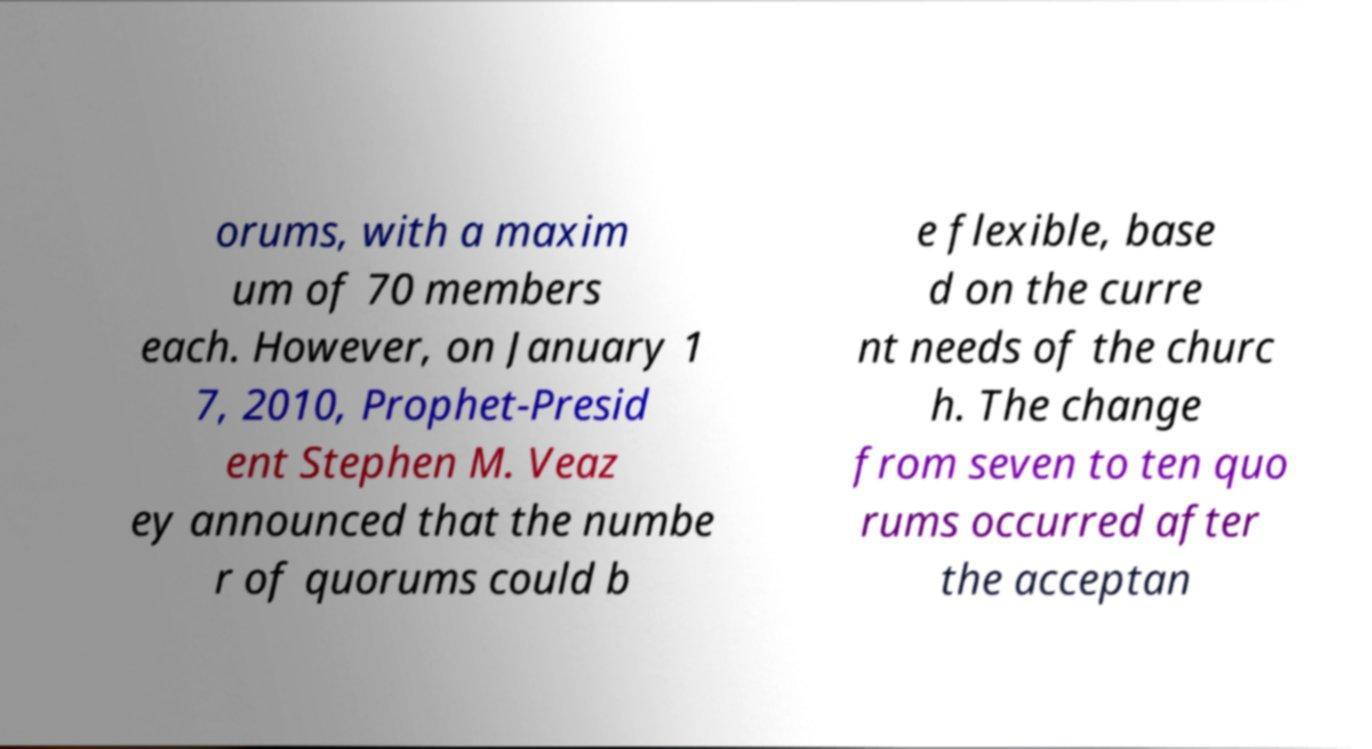There's text embedded in this image that I need extracted. Can you transcribe it verbatim? orums, with a maxim um of 70 members each. However, on January 1 7, 2010, Prophet-Presid ent Stephen M. Veaz ey announced that the numbe r of quorums could b e flexible, base d on the curre nt needs of the churc h. The change from seven to ten quo rums occurred after the acceptan 